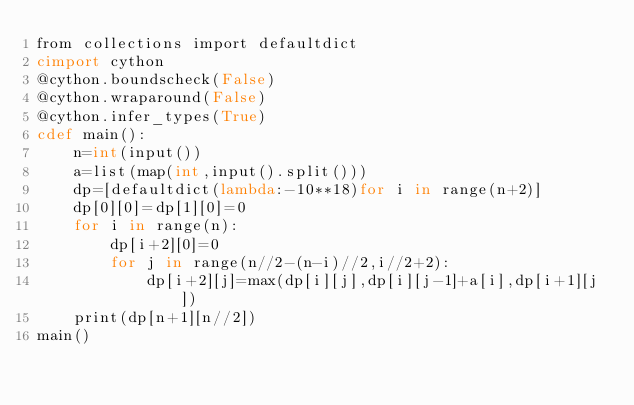<code> <loc_0><loc_0><loc_500><loc_500><_Cython_>from collections import defaultdict
cimport cython
@cython.boundscheck(False)
@cython.wraparound(False)
@cython.infer_types(True)
cdef main():
    n=int(input())
    a=list(map(int,input().split()))
    dp=[defaultdict(lambda:-10**18)for i in range(n+2)]
    dp[0][0]=dp[1][0]=0
    for i in range(n):
        dp[i+2][0]=0
        for j in range(n//2-(n-i)//2,i//2+2):
            dp[i+2][j]=max(dp[i][j],dp[i][j-1]+a[i],dp[i+1][j])
    print(dp[n+1][n//2])
main()</code> 